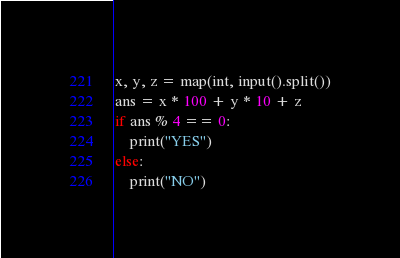<code> <loc_0><loc_0><loc_500><loc_500><_Python_>x, y, z = map(int, input().split())
ans = x * 100 + y * 10 + z
if ans % 4 == 0:
    print("YES")
else:
    print("NO")
</code> 